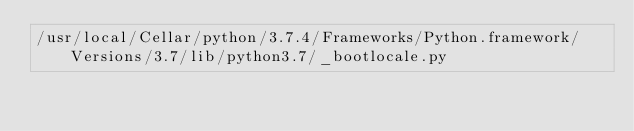Convert code to text. <code><loc_0><loc_0><loc_500><loc_500><_Python_>/usr/local/Cellar/python/3.7.4/Frameworks/Python.framework/Versions/3.7/lib/python3.7/_bootlocale.py</code> 